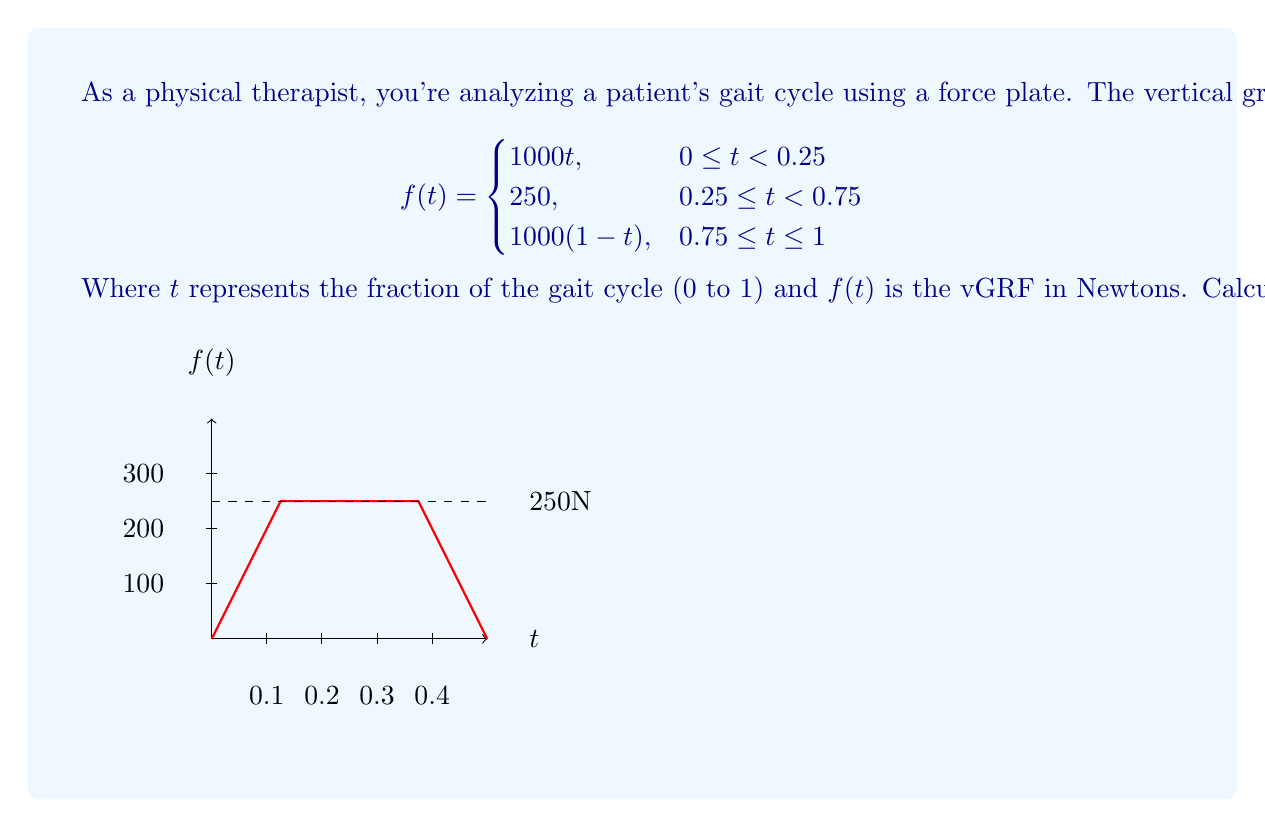Can you answer this question? To find the Fourier transform, we need to calculate:

$$F(\omega) = \int_{-\infty}^{\infty} f(t) e^{-i\omega t} dt$$

For our piecewise function, this becomes:

$$F(\omega) = \int_{0}^{0.25} 1000t e^{-i\omega t} dt + \int_{0.25}^{0.75} 250 e^{-i\omega t} dt + \int_{0.75}^{1} 1000(1-t) e^{-i\omega t} dt$$

Let's solve each integral:

1) $\int_{0}^{0.25} 1000t e^{-i\omega t} dt$:
   Using integration by parts with $u=t$ and $dv=e^{-i\omega t}dt$:
   $$\left[-\frac{1000t}{i\omega}e^{-i\omega t}\right]_{0}^{0.25} + \frac{1000}{i\omega}\int_{0}^{0.25} e^{-i\omega t} dt$$
   $$= -\frac{250}{i\omega}e^{-i\omega/4} + \frac{1000}{(i\omega)^2}(1-e^{-i\omega/4})$$

2) $\int_{0.25}^{0.75} 250 e^{-i\omega t} dt$:
   $$\left[-\frac{250}{i\omega}e^{-i\omega t}\right]_{0.25}^{0.75} = \frac{250}{i\omega}(e^{-i\omega/4} - e^{-3i\omega/4})$$

3) $\int_{0.75}^{1} 1000(1-t) e^{-i\omega t} dt$:
   Using integration by parts with $u=1-t$ and $dv=e^{-i\omega t}dt$:
   $$\left[-\frac{1000(1-t)}{i\omega}e^{-i\omega t}\right]_{0.75}^{1} - \frac{1000}{i\omega}\int_{0.75}^{1} e^{-i\omega t} dt$$
   $$= -\frac{250}{i\omega}e^{-i\omega} + \frac{250}{i\omega}e^{-3i\omega/4} - \frac{1000}{(i\omega)^2}(e^{-i\omega} - e^{-3i\omega/4})$$

Summing these three parts and simplifying:

$$F(\omega) = \frac{1000}{(i\omega)^2}(1-e^{-i\omega}) + \frac{250}{i\omega}(1-e^{-i\omega})$$

This can be factored to:

$$F(\omega) = \frac{250}{i\omega}(1-e^{-i\omega})\left(1+\frac{4}{i\omega}\right)$$
Answer: $F(\omega) = \frac{250}{i\omega}(1-e^{-i\omega})(1+\frac{4}{i\omega})$ 